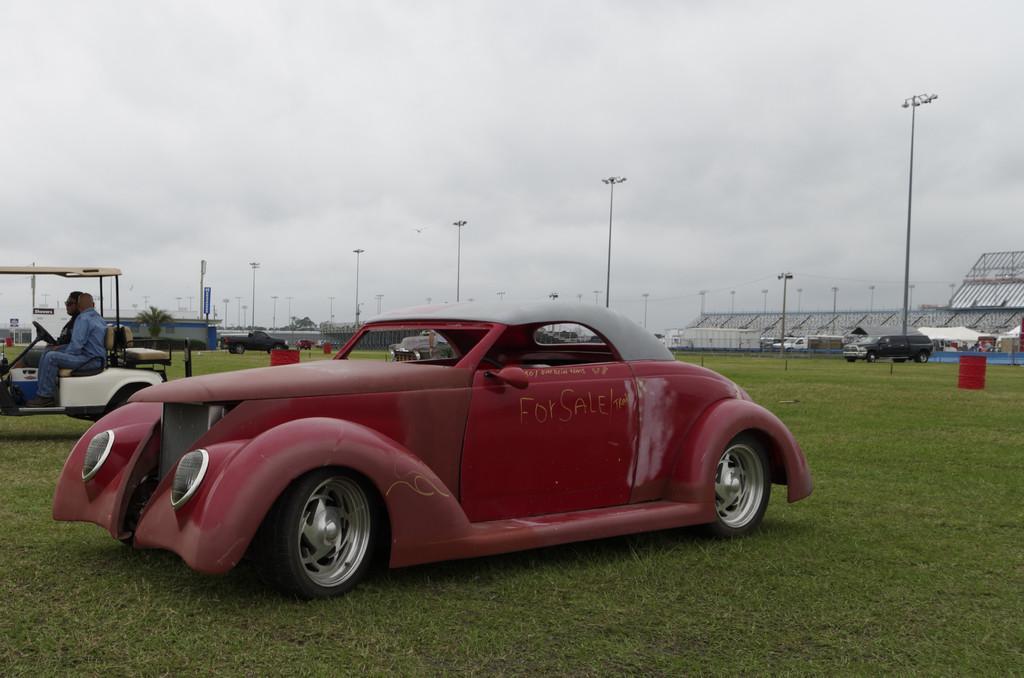In one or two sentences, can you explain what this image depicts? As we can see in the image there are vehicles, few people, lights and buildings. There is grass and at the top there is sky. 